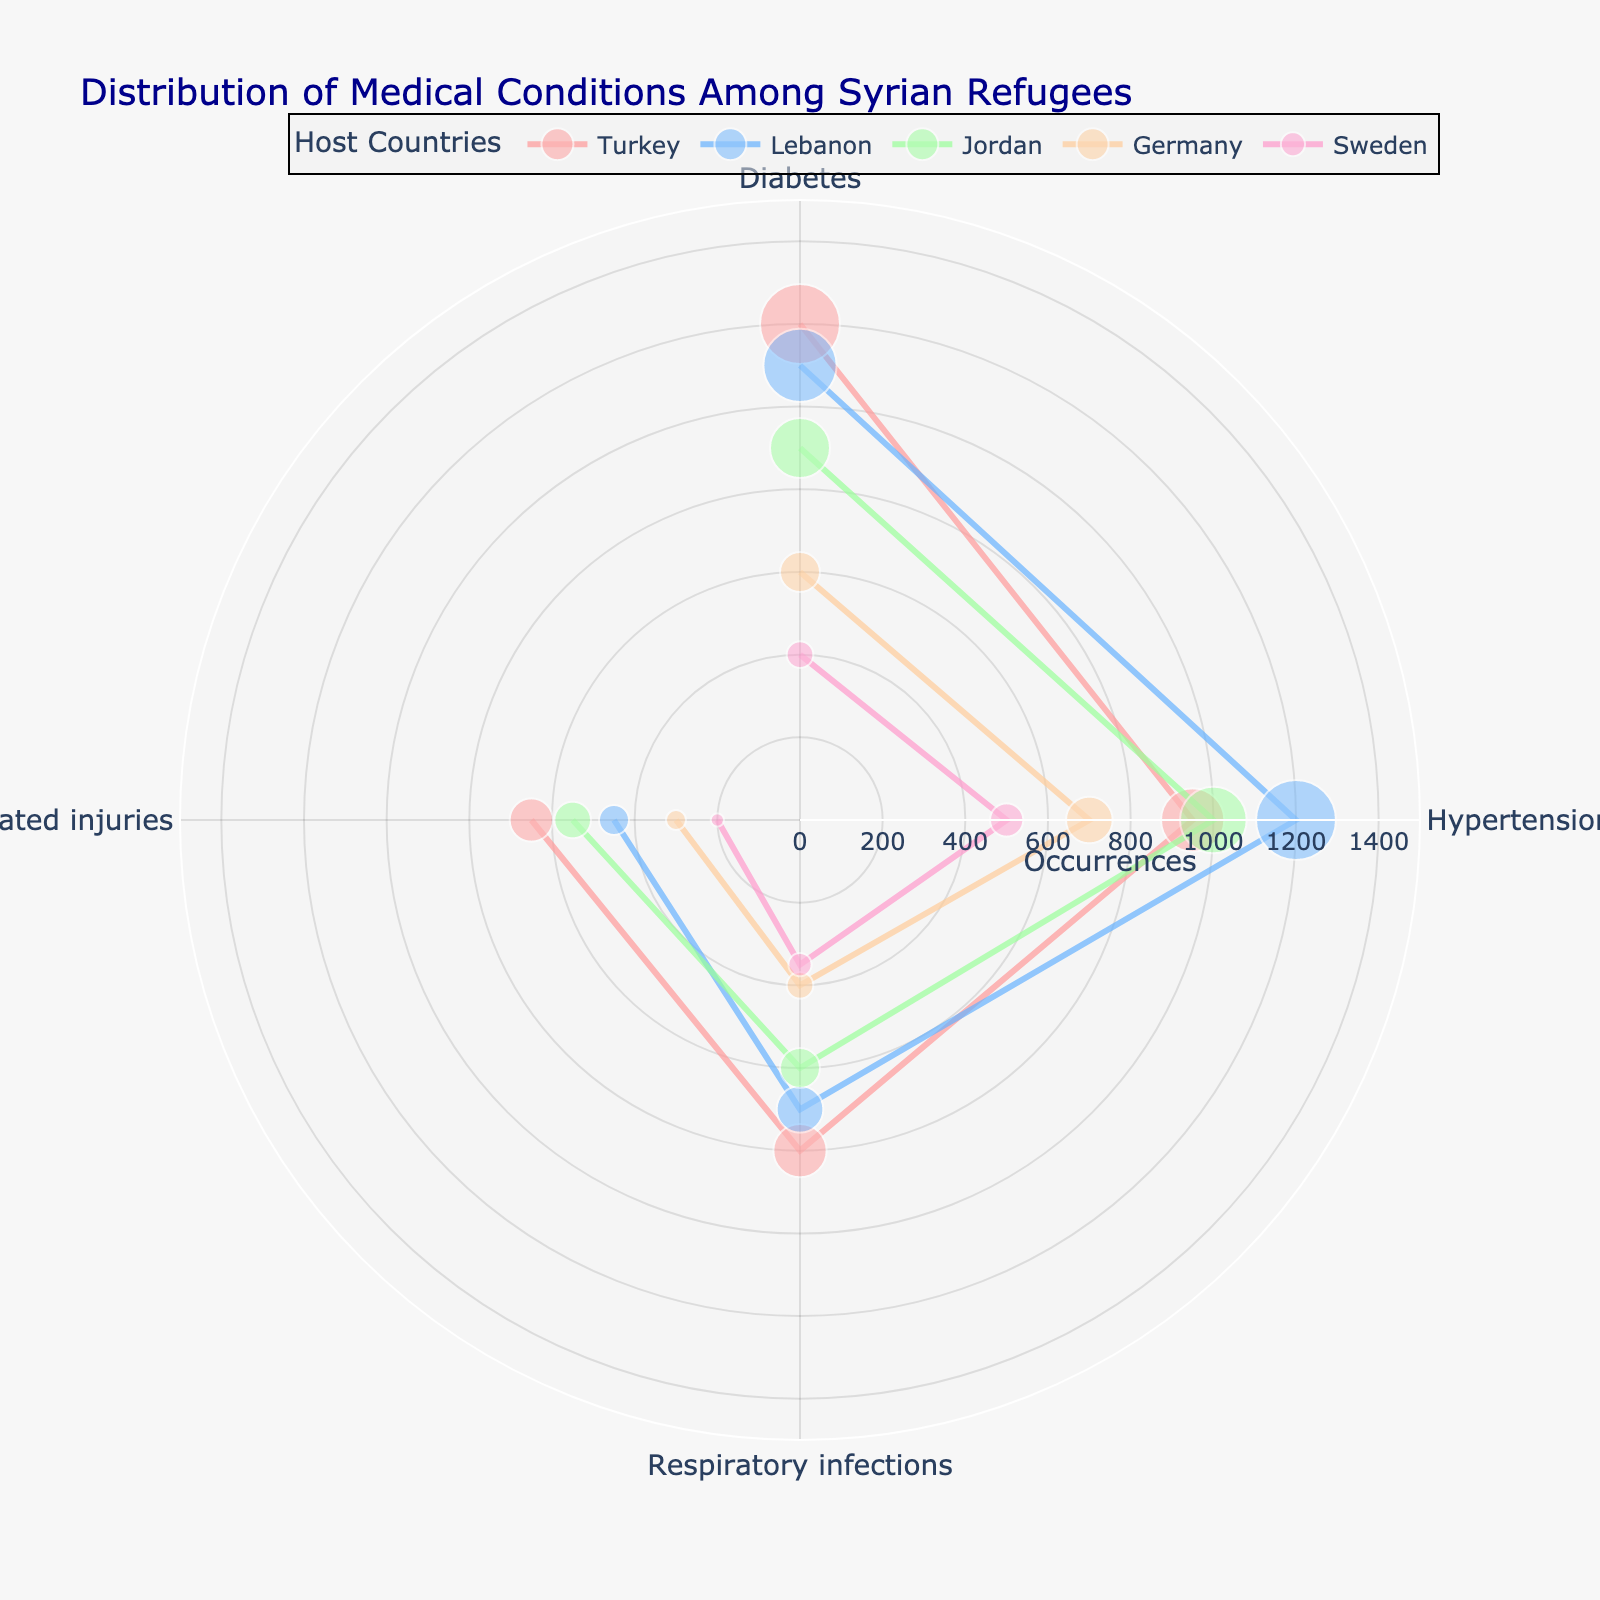Which country has the highest number of occurrences of diabetes among Syrian refugees? From the figure, identify the country with the highest radial (r) value corresponding to 'Diabetes'. The highest r value is at Turkey.
Answer: Turkey Which medical condition has the least occurrences in Sweden? From the figure, find the smallest r value among the conditions listed for Sweden. 'Trauma-related injuries' has the lowest occurrences.
Answer: Trauma-related injuries How do occurrences of respiratory infections compare between Turkey and Jordan? Compare the radial values corresponding to 'Respiratory infections' in both Turkey and Jordan. Turkey has 800 occurrences, while Jordan has 600 occurrences.
Answer: Turkey has more occurrences than Jordan What is the total number of diabetes occurrences in Lebanon and Germany? Add the r values corresponding to 'Diabetes' for Lebanon and Germany. Lebanon has 1100 and Germany has 600, so 1100 + 600 = 1700.
Answer: 1700 Which country shows the highest variation in the occurrences of different medical conditions? Assess the range of radial values for each country. Turkey has occurrences ranging from 650 to 1200, which is a range of 550. Other countries have smaller ranges.
Answer: Turkey Compare the occurrences of hypertension between Lebanon and Sweden. Compare the radial values corresponding to 'Hypertension' in both Lebanon and Sweden. Lebanon has 1200 occurrences, while Sweden has 500 occurrences.
Answer: Lebanon has more occurrences than Sweden What is the average number of trauma-related injuries across all countries? Sum the occurrences of 'Trauma-related injuries' across all countries (650 + 450 + 550 + 300 + 200 = 2150) and divide by the number of countries (5). So, 2150 / 5 = 430.
Answer: 430 Which medical condition has the highest total occurrences across all countries? Sum occurrences of each condition across all countries: Diabetes (1200+1100+900+600+400 = 4200), Hypertension (950+1200+1000+700+500 = 4350), Respiratory infections (800+700+600+400+350 = 2850), Trauma-related injuries (650+450+550+300+200 = 2150). Hypertension has the highest total.
Answer: Hypertension What is the relative proportion of respiratory infections out of total medical conditions for Jordan? Sum total occurrences in Jordan (900+1000+600+550 = 3050). Calculate the proportion of respiratory infections (600 out of 3050). So, 600/3050 ≈ 0.1967 or 19.67%.
Answer: 19.67% Between Germany and Sweden, which country has fewer occurrences of hypertension? From the figure, compare the radial values corresponding to 'Hypertension' in Germany and Sweden. Germany has 700 occurrences while Sweden has 500 occurrences.
Answer: Sweden 